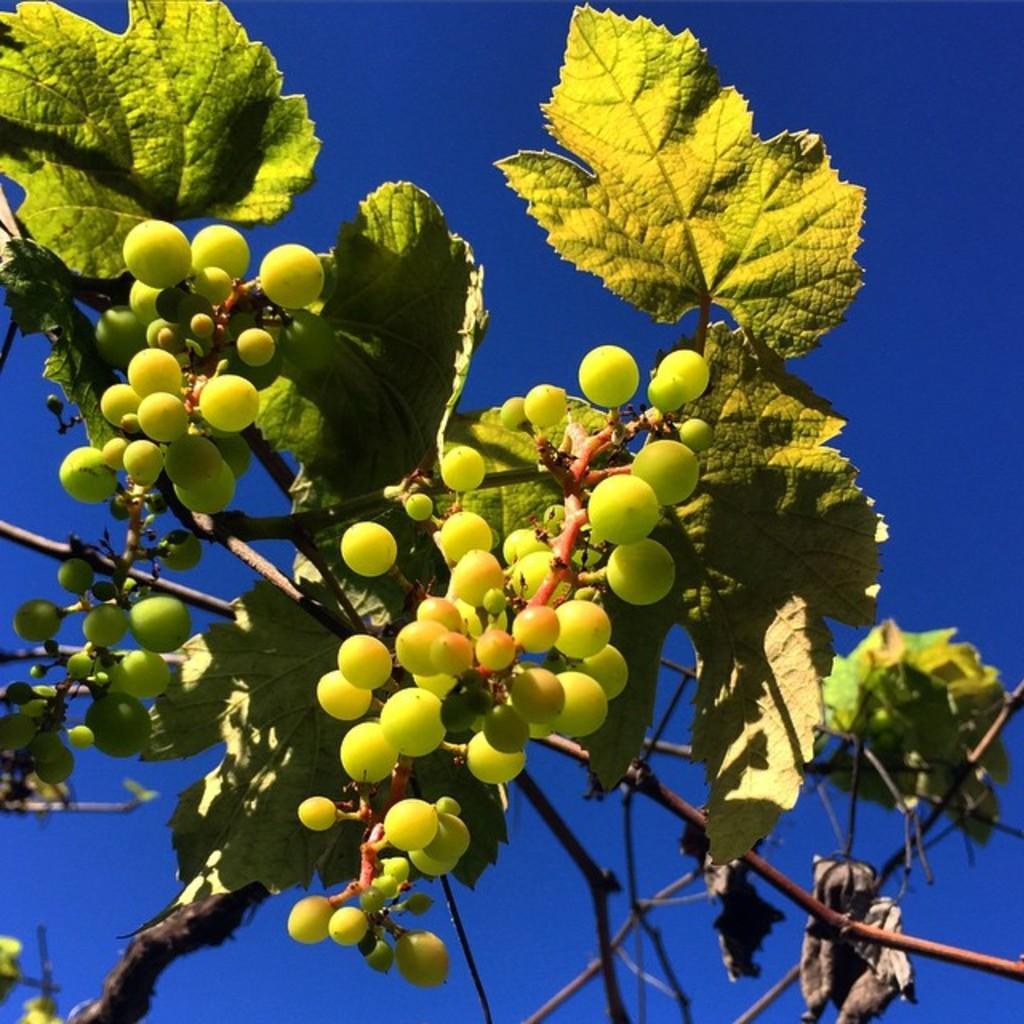Describe this image in one or two sentences. In this image we can see the green color grapes with the leaves and also stems. In the background we can see the sky. 